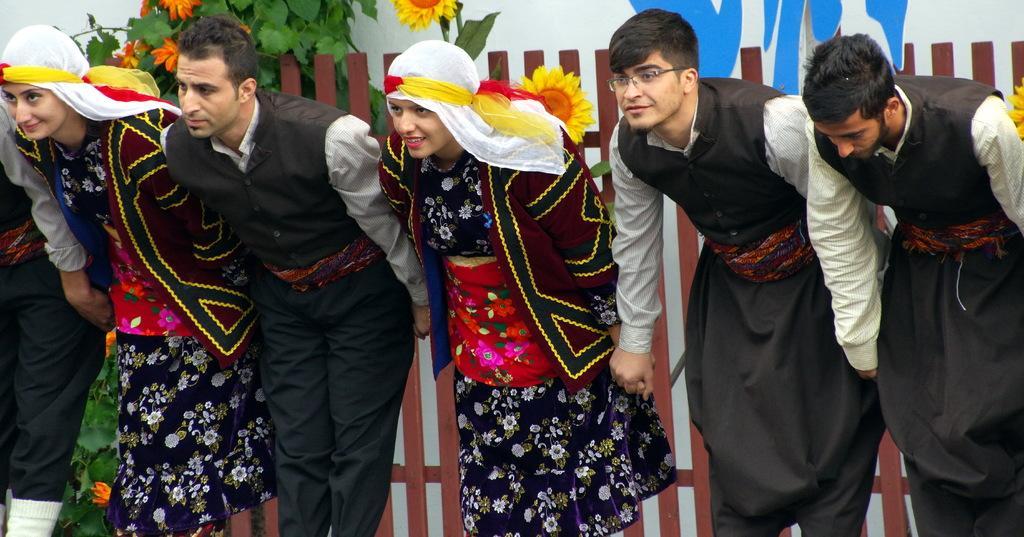Describe this image in one or two sentences. In the image we can see there are people standing, wearing clothes and some of them are smiling. Behind them, we can see fence, leaves, flowers and the poster. The right side man is wearing spectacles. 